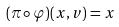<formula> <loc_0><loc_0><loc_500><loc_500>( \pi \circ \varphi ) ( x , v ) = x</formula> 